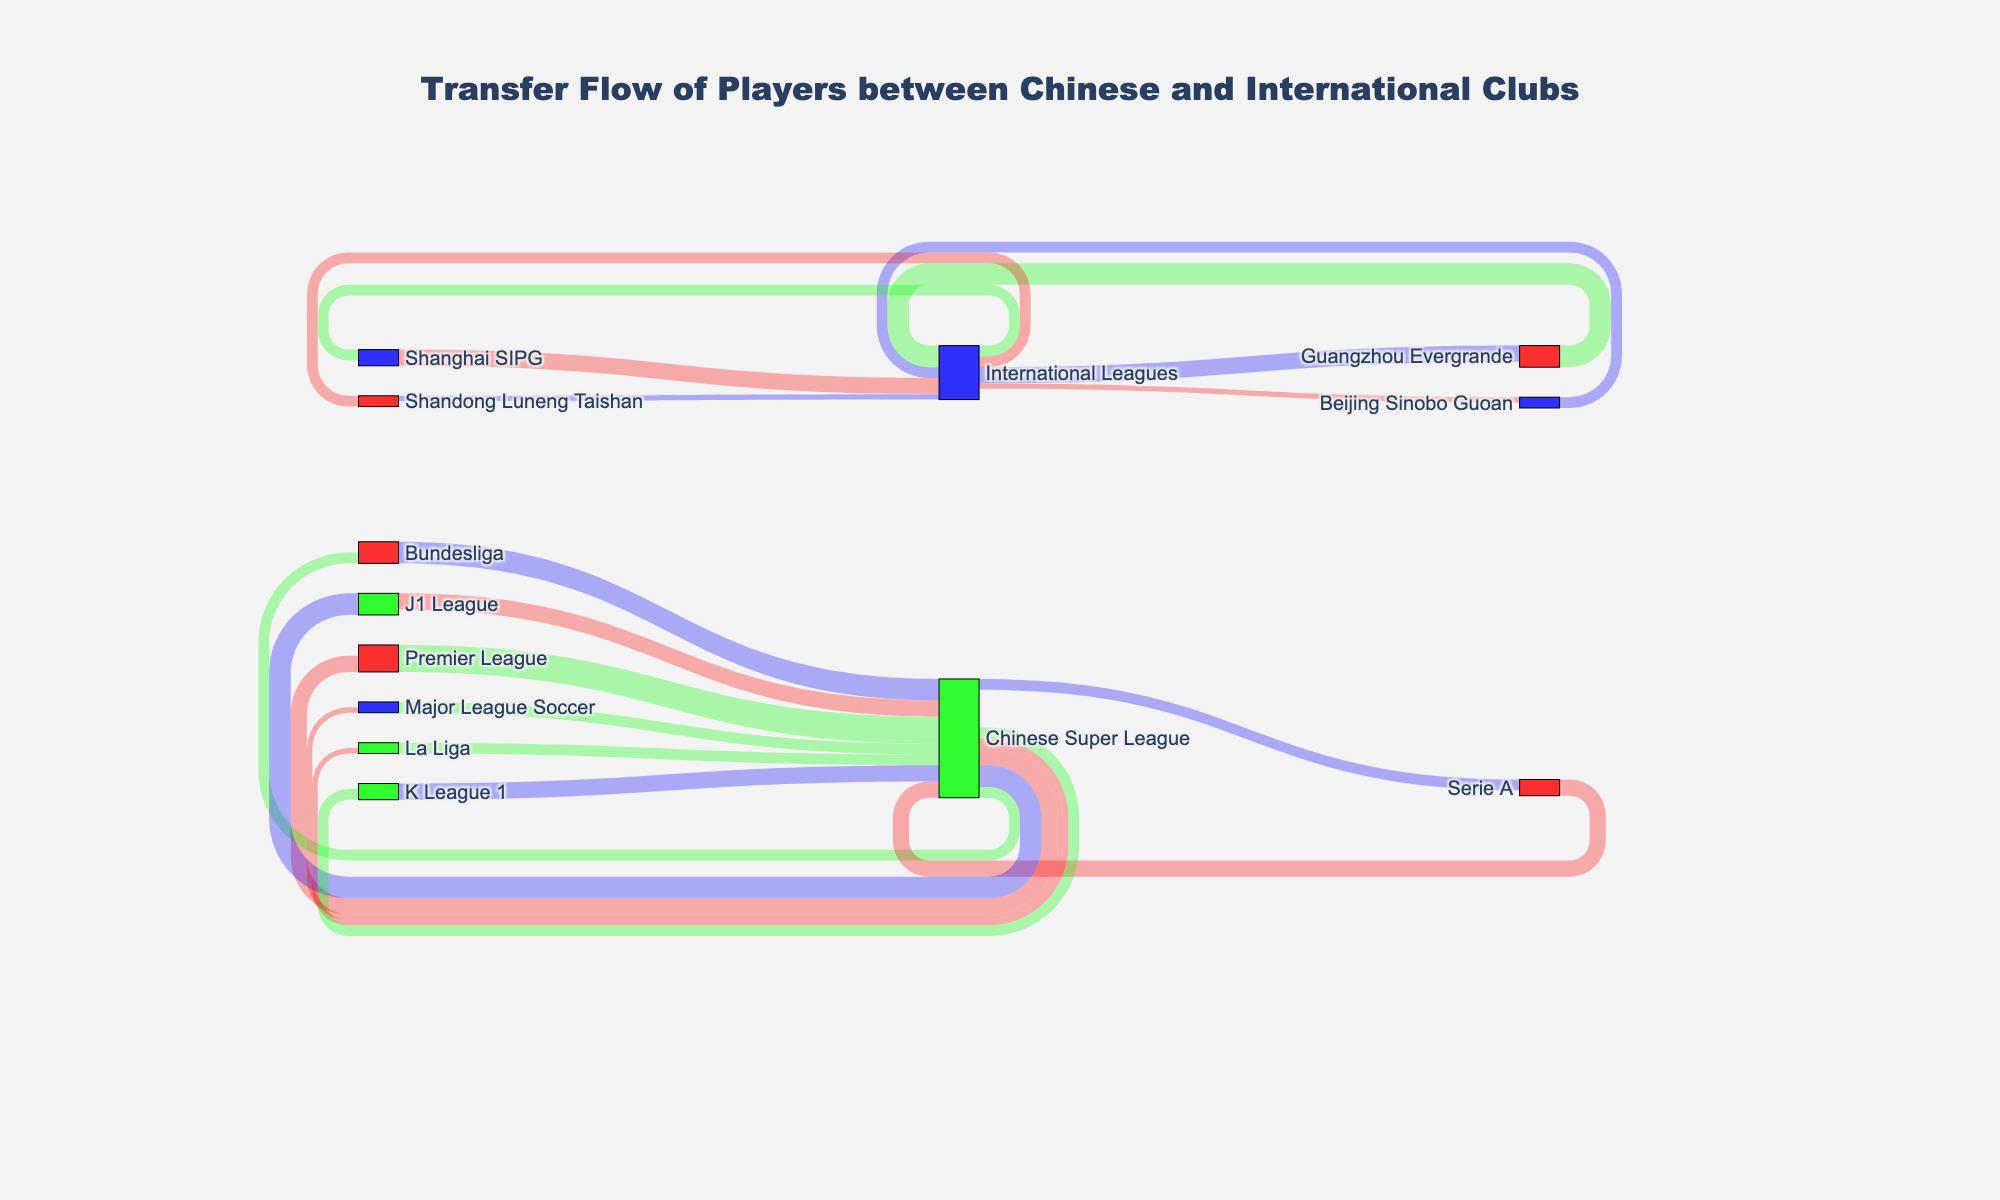What's the title of the figure? The title is located at the top of the figure and provides a summary of what the visualization represents.
Answer: Transfer Flow of Players between Chinese and International Clubs Which league has the highest number of transfers to the Chinese Super League? By looking at the thickness of the links and the values shown, the Premier League has the highest number of transfers to the Chinese Super League with 5 players.
Answer: Premier League How many players have transferred from the Chinese Super League to La Liga? The link connecting the Chinese Super League to La Liga indicates 1 player has transferred.
Answer: 1 Compare the total number of players transferred from international leagues to the Chinese Super League with those who transferred from the Chinese Super League to international leagues. Sum the incoming values: Premier League (5) + Bundesliga (4) + Serie A (3) + La Liga (2) + J1 League (3) + K League 1 (3) + Major League Soccer (2) = 22. For the outgoing values: Premier League (3) + Bundesliga (2) + Serie A (2) + La Liga (1) + J1 League (4) + K League 1 (2) + Major League Soccer (1) = 15.
Answer: 22 vs 15 Which club in the Chinese Super League has engaged in the most player transfers with international leagues? By examining the sum of the connections related to each club, Guangzhou Evergrande has the most with 4 outgoing and 3 incoming transfers, totaling 7.
Answer: Guangzhou Evergrande How many players have transferred from Beijing Sinobo Guoan to International Leagues and how many from International Leagues to Beijing Sinobo Guoan? From Beijing Sinobo Guoan to International Leagues, it's 2 players; from International Leagues to Beijing Sinobo Guoan, it's 1 player.
Answer: 2 and 1 Is the number of players transferred from the Chinese Super League to the K League 1 greater than those transferred to Major League Soccer? The diagram shows 2 players transferred to the K League 1 and 1 player to Major League Soccer, making the former greater.
Answer: Yes Of the clubs mentioned, which one has the least number of transfers involving international leagues? Shandong Luneng Taishan has 1 outgoing and 2 incoming transfers, totaling 3, which is the least among clubs mentioned.
Answer: Shandong Luneng Taishan 